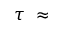Convert formula to latex. <formula><loc_0><loc_0><loc_500><loc_500>\tau \ \approx</formula> 